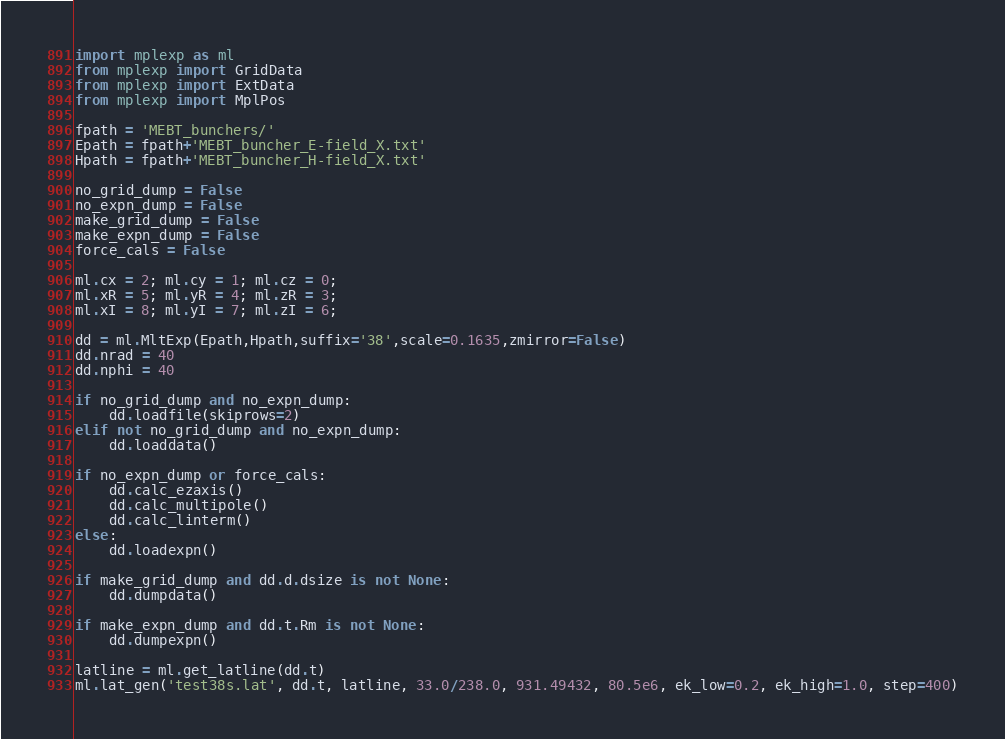Convert code to text. <code><loc_0><loc_0><loc_500><loc_500><_Python_>import mplexp as ml
from mplexp import GridData
from mplexp import ExtData
from mplexp import MplPos

fpath = 'MEBT_bunchers/'
Epath = fpath+'MEBT_buncher_E-field_X.txt'
Hpath = fpath+'MEBT_buncher_H-field_X.txt'

no_grid_dump = False
no_expn_dump = False
make_grid_dump = False
make_expn_dump = False
force_cals = False

ml.cx = 2; ml.cy = 1; ml.cz = 0;
ml.xR = 5; ml.yR = 4; ml.zR = 3;
ml.xI = 8; ml.yI = 7; ml.zI = 6;

dd = ml.MltExp(Epath,Hpath,suffix='38',scale=0.1635,zmirror=False)
dd.nrad = 40
dd.nphi = 40

if no_grid_dump and no_expn_dump:
    dd.loadfile(skiprows=2)
elif not no_grid_dump and no_expn_dump:
    dd.loaddata()

if no_expn_dump or force_cals:
    dd.calc_ezaxis()
    dd.calc_multipole()
    dd.calc_linterm()
else:
    dd.loadexpn()

if make_grid_dump and dd.d.dsize is not None:
    dd.dumpdata()

if make_expn_dump and dd.t.Rm is not None:
    dd.dumpexpn()

latline = ml.get_latline(dd.t)
ml.lat_gen('test38s.lat', dd.t, latline, 33.0/238.0, 931.49432, 80.5e6, ek_low=0.2, ek_high=1.0, step=400)
</code> 